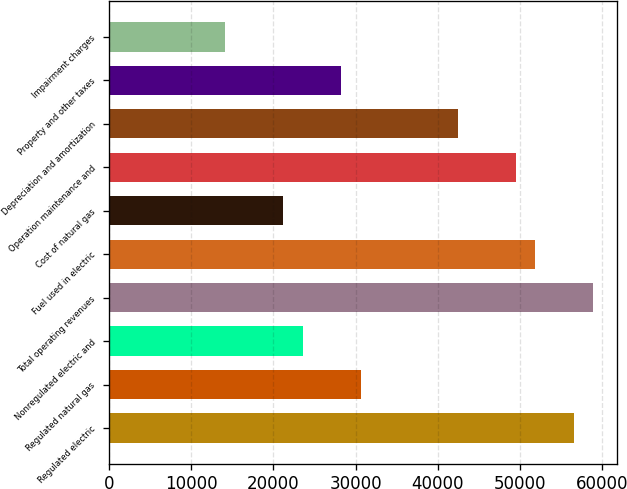Convert chart to OTSL. <chart><loc_0><loc_0><loc_500><loc_500><bar_chart><fcel>Regulated electric<fcel>Regulated natural gas<fcel>Nonregulated electric and<fcel>Total operating revenues<fcel>Fuel used in electric<fcel>Cost of natural gas<fcel>Operation maintenance and<fcel>Depreciation and amortization<fcel>Property and other taxes<fcel>Impairment charges<nl><fcel>56549.8<fcel>30633.2<fcel>23565<fcel>58905.9<fcel>51837.7<fcel>21208.9<fcel>49481.6<fcel>42413.4<fcel>28277.1<fcel>14140.7<nl></chart> 